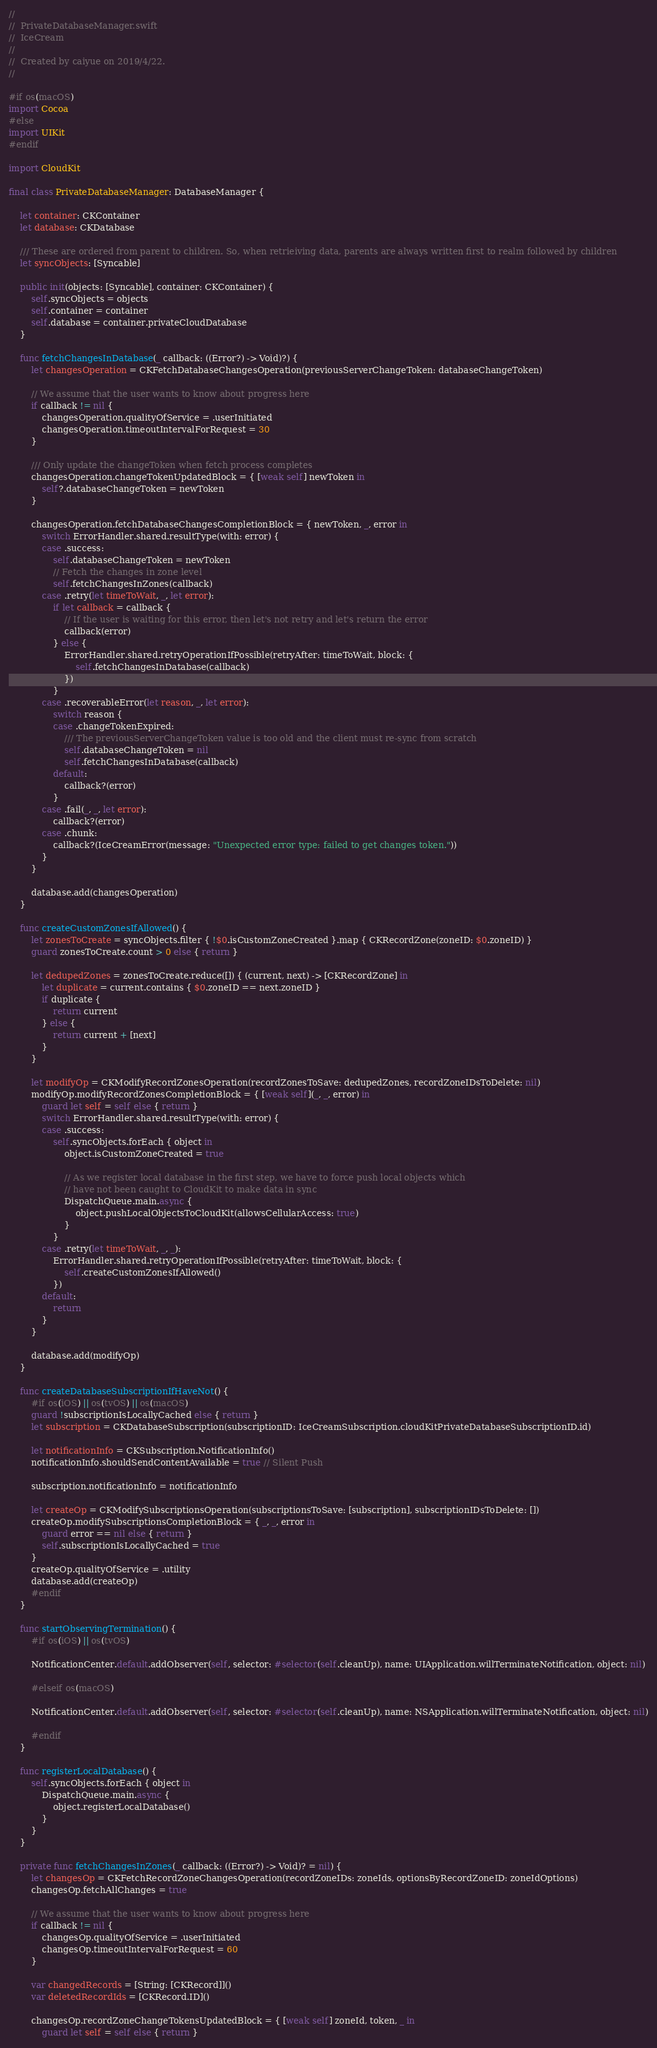Convert code to text. <code><loc_0><loc_0><loc_500><loc_500><_Swift_>//
//  PrivateDatabaseManager.swift
//  IceCream
//
//  Created by caiyue on 2019/4/22.
//

#if os(macOS)
import Cocoa
#else
import UIKit
#endif

import CloudKit

final class PrivateDatabaseManager: DatabaseManager {
    
    let container: CKContainer
    let database: CKDatabase

    /// These are ordered from parent to children. So, when retrieiving data, parents are always written first to realm followed by children
    let syncObjects: [Syncable]
    
    public init(objects: [Syncable], container: CKContainer) {
        self.syncObjects = objects
        self.container = container
        self.database = container.privateCloudDatabase
    }
    
    func fetchChangesInDatabase(_ callback: ((Error?) -> Void)?) {
        let changesOperation = CKFetchDatabaseChangesOperation(previousServerChangeToken: databaseChangeToken)

        // We assume that the user wants to know about progress here
        if callback != nil {
            changesOperation.qualityOfService = .userInitiated
            changesOperation.timeoutIntervalForRequest = 30
        }
        
        /// Only update the changeToken when fetch process completes
        changesOperation.changeTokenUpdatedBlock = { [weak self] newToken in
            self?.databaseChangeToken = newToken
        }
        
        changesOperation.fetchDatabaseChangesCompletionBlock = { newToken, _, error in
            switch ErrorHandler.shared.resultType(with: error) {
            case .success:
                self.databaseChangeToken = newToken
                // Fetch the changes in zone level
                self.fetchChangesInZones(callback)
            case .retry(let timeToWait, _, let error):
                if let callback = callback {
                    // If the user is waiting for this error, then let's not retry and let's return the error
                    callback(error)
                } else {
                    ErrorHandler.shared.retryOperationIfPossible(retryAfter: timeToWait, block: {
                        self.fetchChangesInDatabase(callback)
                    })
                }
            case .recoverableError(let reason, _, let error):
                switch reason {
                case .changeTokenExpired:
                    /// The previousServerChangeToken value is too old and the client must re-sync from scratch
                    self.databaseChangeToken = nil
                    self.fetchChangesInDatabase(callback)
                default:
                    callback?(error)
                }
            case .fail(_, _, let error):
                callback?(error)
            case .chunk:
                callback?(IceCreamError(message: "Unexpected error type: failed to get changes token."))
            }
        }
        
        database.add(changesOperation)
    }
    
    func createCustomZonesIfAllowed() {
        let zonesToCreate = syncObjects.filter { !$0.isCustomZoneCreated }.map { CKRecordZone(zoneID: $0.zoneID) }
        guard zonesToCreate.count > 0 else { return }

        let dedupedZones = zonesToCreate.reduce([]) { (current, next) -> [CKRecordZone] in
            let duplicate = current.contains { $0.zoneID == next.zoneID }
            if duplicate {
                return current
            } else {
                return current + [next]
            }
        }
        
        let modifyOp = CKModifyRecordZonesOperation(recordZonesToSave: dedupedZones, recordZoneIDsToDelete: nil)
        modifyOp.modifyRecordZonesCompletionBlock = { [weak self](_, _, error) in
            guard let self = self else { return }
            switch ErrorHandler.shared.resultType(with: error) {
            case .success:
                self.syncObjects.forEach { object in
                    object.isCustomZoneCreated = true
                    
                    // As we register local database in the first step, we have to force push local objects which
                    // have not been caught to CloudKit to make data in sync
                    DispatchQueue.main.async {
                        object.pushLocalObjectsToCloudKit(allowsCellularAccess: true)
                    }
                }
            case .retry(let timeToWait, _, _):
                ErrorHandler.shared.retryOperationIfPossible(retryAfter: timeToWait, block: {
                    self.createCustomZonesIfAllowed()
                })
            default:
                return
            }
        }
        
        database.add(modifyOp)
    }
    
    func createDatabaseSubscriptionIfHaveNot() {
        #if os(iOS) || os(tvOS) || os(macOS)
        guard !subscriptionIsLocallyCached else { return }
        let subscription = CKDatabaseSubscription(subscriptionID: IceCreamSubscription.cloudKitPrivateDatabaseSubscriptionID.id)
        
        let notificationInfo = CKSubscription.NotificationInfo()
        notificationInfo.shouldSendContentAvailable = true // Silent Push
        
        subscription.notificationInfo = notificationInfo
        
        let createOp = CKModifySubscriptionsOperation(subscriptionsToSave: [subscription], subscriptionIDsToDelete: [])
        createOp.modifySubscriptionsCompletionBlock = { _, _, error in
            guard error == nil else { return }
            self.subscriptionIsLocallyCached = true
        }
        createOp.qualityOfService = .utility
        database.add(createOp)
        #endif
    }
    
    func startObservingTermination() {
        #if os(iOS) || os(tvOS)
        
        NotificationCenter.default.addObserver(self, selector: #selector(self.cleanUp), name: UIApplication.willTerminateNotification, object: nil)
        
        #elseif os(macOS)
        
        NotificationCenter.default.addObserver(self, selector: #selector(self.cleanUp), name: NSApplication.willTerminateNotification, object: nil)
        
        #endif
    }
    
    func registerLocalDatabase() {
        self.syncObjects.forEach { object in
            DispatchQueue.main.async {
                object.registerLocalDatabase()
            }
        }
    }
    
    private func fetchChangesInZones(_ callback: ((Error?) -> Void)? = nil) {
        let changesOp = CKFetchRecordZoneChangesOperation(recordZoneIDs: zoneIds, optionsByRecordZoneID: zoneIdOptions)
        changesOp.fetchAllChanges = true

        // We assume that the user wants to know about progress here
        if callback != nil {
            changesOp.qualityOfService = .userInitiated
            changesOp.timeoutIntervalForRequest = 60
        }

        var changedRecords = [String: [CKRecord]]()
        var deletedRecordIds = [CKRecord.ID]()
        
        changesOp.recordZoneChangeTokensUpdatedBlock = { [weak self] zoneId, token, _ in
            guard let self = self else { return }</code> 